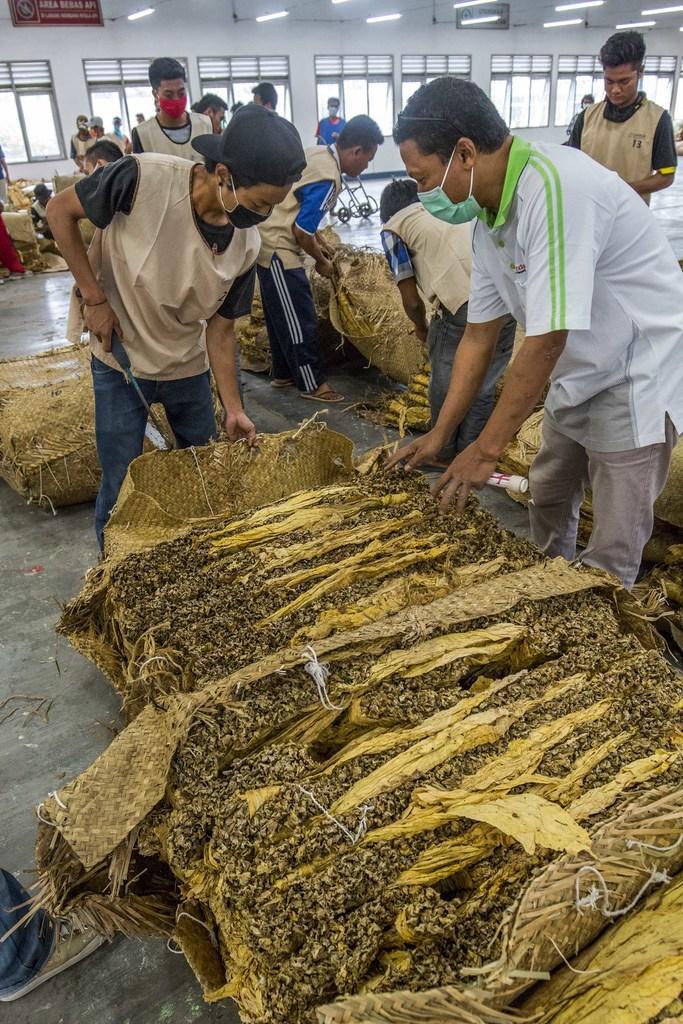Please provide a concise description of this image. In this image few persons are standing on a floor. There are few dried leaves in bag. A person is holding a metal rod in his hand. He is wearing a cap. He is standing behind the bag. There are few bags on the floor. There is a trolley. Behind them there are few windows to the wall. Top of image there are few lights hanged from the roof. 